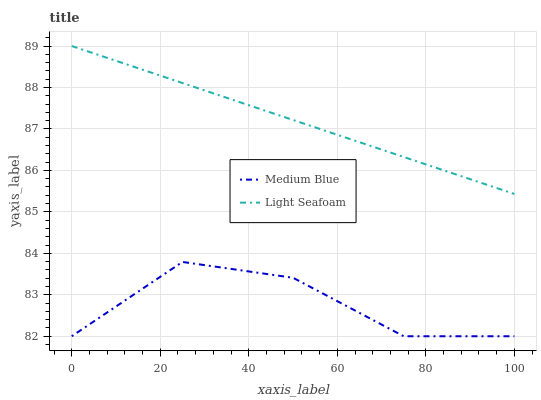Does Medium Blue have the minimum area under the curve?
Answer yes or no. Yes. Does Light Seafoam have the maximum area under the curve?
Answer yes or no. Yes. Does Medium Blue have the maximum area under the curve?
Answer yes or no. No. Is Light Seafoam the smoothest?
Answer yes or no. Yes. Is Medium Blue the roughest?
Answer yes or no. Yes. Is Medium Blue the smoothest?
Answer yes or no. No. Does Light Seafoam have the highest value?
Answer yes or no. Yes. Does Medium Blue have the highest value?
Answer yes or no. No. Is Medium Blue less than Light Seafoam?
Answer yes or no. Yes. Is Light Seafoam greater than Medium Blue?
Answer yes or no. Yes. Does Medium Blue intersect Light Seafoam?
Answer yes or no. No. 